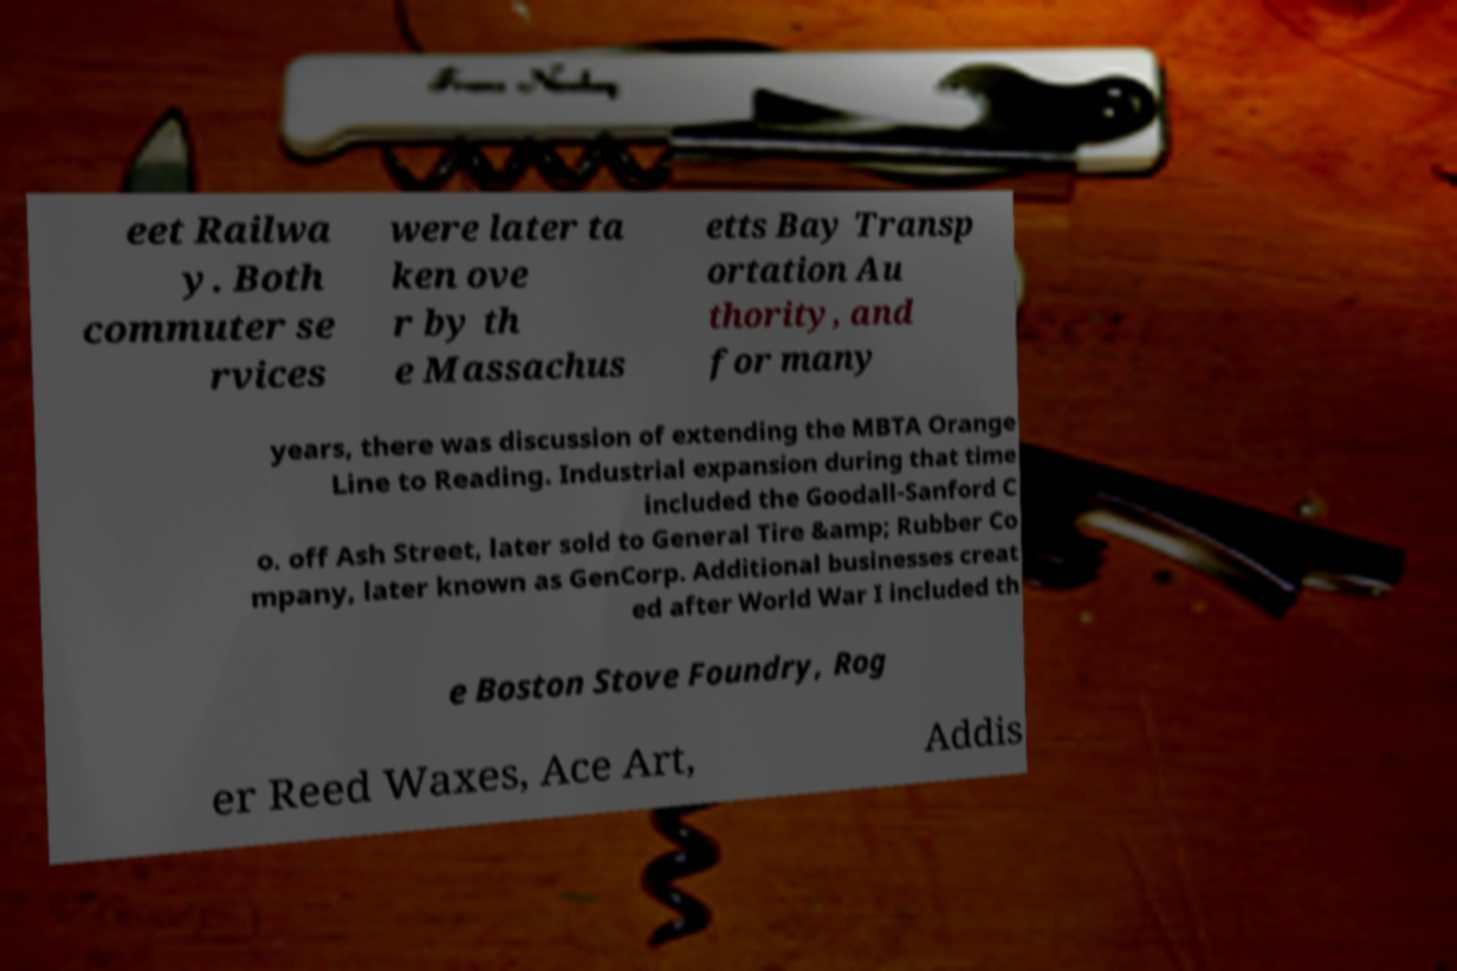I need the written content from this picture converted into text. Can you do that? eet Railwa y. Both commuter se rvices were later ta ken ove r by th e Massachus etts Bay Transp ortation Au thority, and for many years, there was discussion of extending the MBTA Orange Line to Reading. Industrial expansion during that time included the Goodall-Sanford C o. off Ash Street, later sold to General Tire &amp; Rubber Co mpany, later known as GenCorp. Additional businesses creat ed after World War I included th e Boston Stove Foundry, Rog er Reed Waxes, Ace Art, Addis 